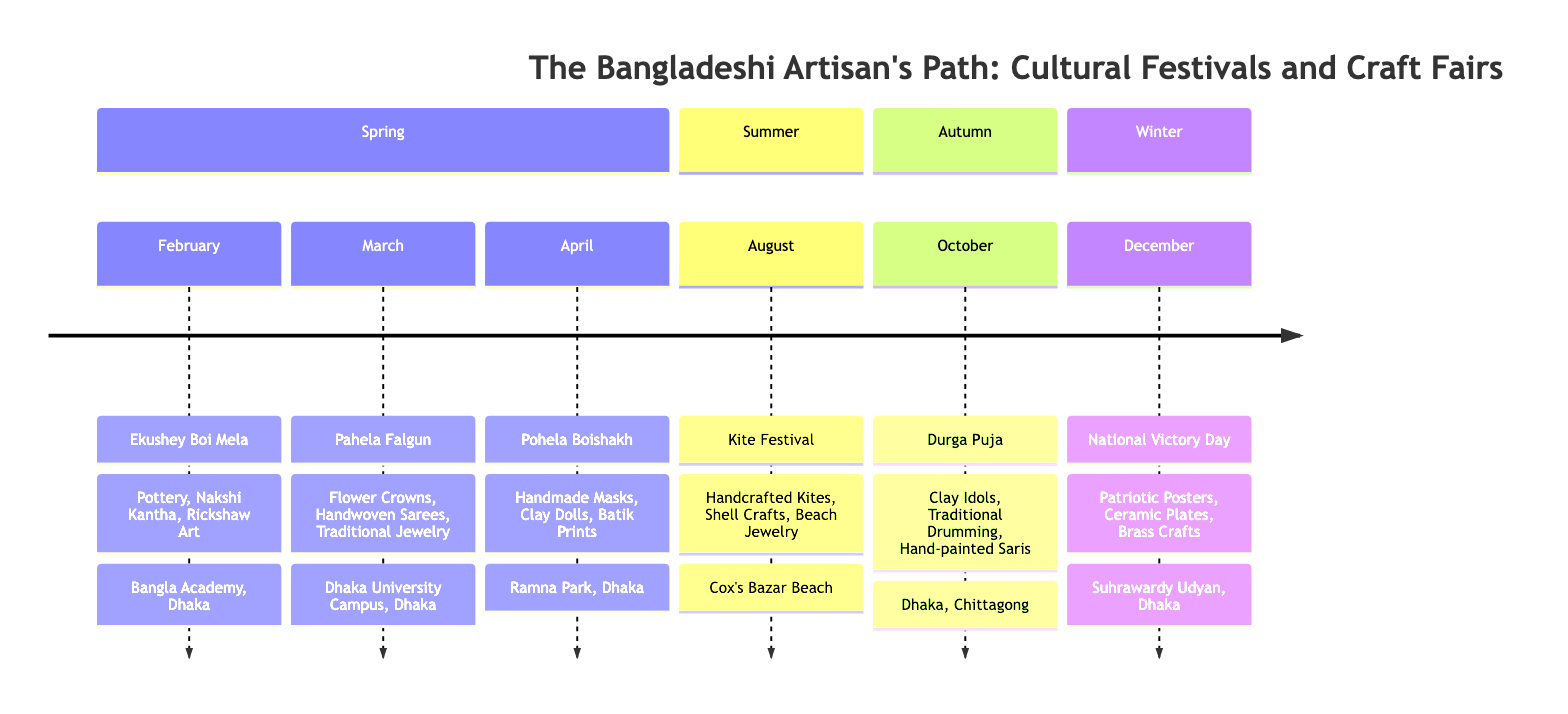What festival occurs in February? The diagram indicates that the festival in February is Ekushey Boi Mela, which is directly noted under the February entry.
Answer: Ekushey Boi Mela Which crafts are highlighted during Pahela Falgun? Looking at the March section for Pahela Falgun, the highlighted crafts are Flower Crowns, Handwoven Sarees, and Traditional Jewelry. These are listed directly under the festival name.
Answer: Flower Crowns, Handwoven Sarees, Traditional Jewelry How many festivals are listed in the timeline? The timeline contains six entries, each representing a different festival throughout the year. This total is determined by counting each festival listed in the provided data.
Answer: 6 What is the location of the Kite Festival? The Kite Festival is noted to take place at Cox's Bazar Beach in the August entry of the timeline, as explicitly stated.
Answer: Cox's Bazar Beach Which crafts are featured during the National Victory Day? In December, the crafts highlighted during National Victory Day include Patriotic Posters, Ceramic Plates, and Brass Crafts, as specified below the festival name.
Answer: Patriotic Posters, Ceramic Plates, Brass Crafts What festival is celebrated in October? The timeline indicates that the festival celebrated in October is Durga Puja, as listed in the respective section of the diagram.
Answer: Durga Puja Which month is associated with Pohela Boishakh? According to the timeline, Pohela Boishakh is associated with the month of April, which is indicated in the corresponding section.
Answer: April Which crafts are highlighted in the summer season? The only festival mentioned in the summer section is the Kite Festival in August, which highlights Handcrafted Kites, Shell Crafts, and Beach Jewelry. This is deduced by referring to the festivals located in the summer section.
Answer: Handcrafted Kites, Shell Crafts, Beach Jewelry What craft is unique to the Ekushey Boi Mela? The Ekushey Boi Mela highlights Rickshaw Art as one of its crafts, which is noted specifically in the February section of the timeline.
Answer: Rickshaw Art 